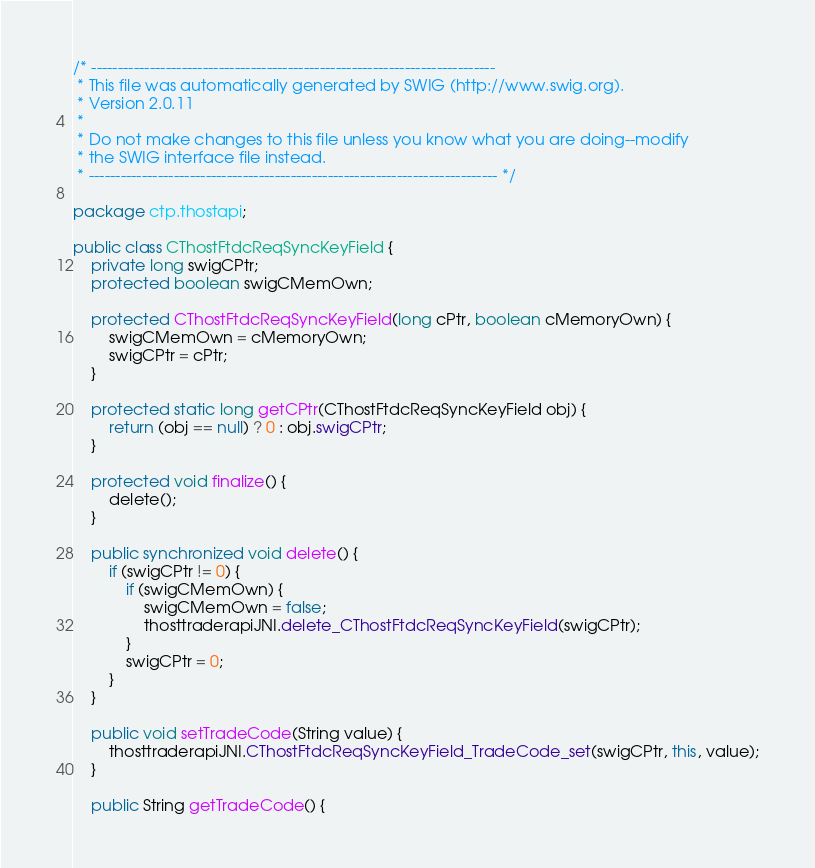Convert code to text. <code><loc_0><loc_0><loc_500><loc_500><_Java_>/* ----------------------------------------------------------------------------
 * This file was automatically generated by SWIG (http://www.swig.org).
 * Version 2.0.11
 *
 * Do not make changes to this file unless you know what you are doing--modify
 * the SWIG interface file instead.
 * ----------------------------------------------------------------------------- */

package ctp.thostapi;

public class CThostFtdcReqSyncKeyField {
	private long swigCPtr;
	protected boolean swigCMemOwn;

	protected CThostFtdcReqSyncKeyField(long cPtr, boolean cMemoryOwn) {
		swigCMemOwn = cMemoryOwn;
		swigCPtr = cPtr;
	}

	protected static long getCPtr(CThostFtdcReqSyncKeyField obj) {
		return (obj == null) ? 0 : obj.swigCPtr;
	}

	protected void finalize() {
		delete();
	}

	public synchronized void delete() {
		if (swigCPtr != 0) {
			if (swigCMemOwn) {
				swigCMemOwn = false;
				thosttraderapiJNI.delete_CThostFtdcReqSyncKeyField(swigCPtr);
			}
			swigCPtr = 0;
		}
	}

	public void setTradeCode(String value) {
		thosttraderapiJNI.CThostFtdcReqSyncKeyField_TradeCode_set(swigCPtr, this, value);
	}

	public String getTradeCode() {</code> 